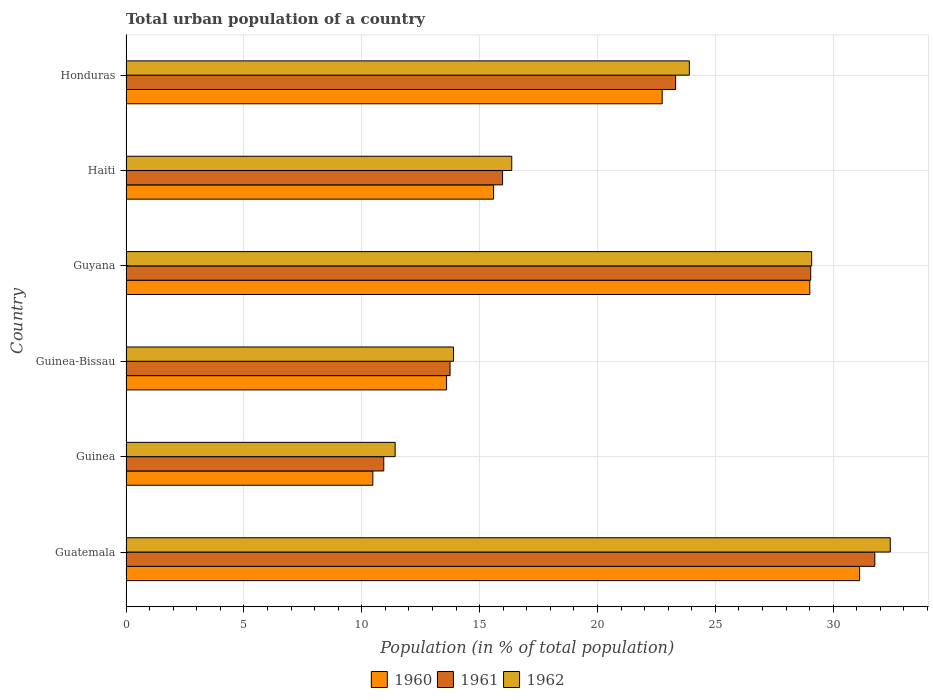How many different coloured bars are there?
Keep it short and to the point. 3. Are the number of bars on each tick of the Y-axis equal?
Your answer should be very brief. Yes. How many bars are there on the 2nd tick from the top?
Your answer should be compact. 3. What is the label of the 6th group of bars from the top?
Give a very brief answer. Guatemala. What is the urban population in 1960 in Guyana?
Keep it short and to the point. 29.01. Across all countries, what is the maximum urban population in 1962?
Provide a short and direct response. 32.42. Across all countries, what is the minimum urban population in 1960?
Offer a terse response. 10.47. In which country was the urban population in 1960 maximum?
Offer a terse response. Guatemala. In which country was the urban population in 1962 minimum?
Keep it short and to the point. Guinea. What is the total urban population in 1962 in the graph?
Provide a short and direct response. 127.09. What is the difference between the urban population in 1962 in Guinea and that in Honduras?
Your answer should be very brief. -12.48. What is the difference between the urban population in 1961 in Honduras and the urban population in 1960 in Guinea-Bissau?
Provide a short and direct response. 9.72. What is the average urban population in 1960 per country?
Give a very brief answer. 20.42. What is the difference between the urban population in 1961 and urban population in 1960 in Guatemala?
Provide a succinct answer. 0.65. What is the ratio of the urban population in 1960 in Guinea to that in Guinea-Bissau?
Give a very brief answer. 0.77. What is the difference between the highest and the second highest urban population in 1962?
Provide a succinct answer. 3.34. What is the difference between the highest and the lowest urban population in 1962?
Offer a very short reply. 21.01. In how many countries, is the urban population in 1962 greater than the average urban population in 1962 taken over all countries?
Your answer should be very brief. 3. Is the sum of the urban population in 1962 in Guinea-Bissau and Honduras greater than the maximum urban population in 1960 across all countries?
Ensure brevity in your answer.  Yes. What does the 3rd bar from the bottom in Guatemala represents?
Offer a very short reply. 1962. Is it the case that in every country, the sum of the urban population in 1960 and urban population in 1961 is greater than the urban population in 1962?
Your answer should be compact. Yes. Are all the bars in the graph horizontal?
Make the answer very short. Yes. What is the difference between two consecutive major ticks on the X-axis?
Offer a very short reply. 5. Does the graph contain grids?
Your answer should be compact. Yes. How are the legend labels stacked?
Offer a very short reply. Horizontal. What is the title of the graph?
Your answer should be very brief. Total urban population of a country. What is the label or title of the X-axis?
Make the answer very short. Population (in % of total population). What is the Population (in % of total population) in 1960 in Guatemala?
Ensure brevity in your answer.  31.12. What is the Population (in % of total population) in 1961 in Guatemala?
Make the answer very short. 31.77. What is the Population (in % of total population) in 1962 in Guatemala?
Give a very brief answer. 32.42. What is the Population (in % of total population) of 1960 in Guinea?
Provide a short and direct response. 10.47. What is the Population (in % of total population) of 1961 in Guinea?
Offer a very short reply. 10.94. What is the Population (in % of total population) in 1962 in Guinea?
Keep it short and to the point. 11.42. What is the Population (in % of total population) in 1961 in Guinea-Bissau?
Offer a very short reply. 13.75. What is the Population (in % of total population) of 1962 in Guinea-Bissau?
Give a very brief answer. 13.89. What is the Population (in % of total population) of 1960 in Guyana?
Your answer should be compact. 29.01. What is the Population (in % of total population) of 1961 in Guyana?
Give a very brief answer. 29.05. What is the Population (in % of total population) in 1962 in Guyana?
Provide a succinct answer. 29.09. What is the Population (in % of total population) in 1960 in Haiti?
Provide a succinct answer. 15.59. What is the Population (in % of total population) in 1961 in Haiti?
Your answer should be very brief. 15.97. What is the Population (in % of total population) of 1962 in Haiti?
Offer a very short reply. 16.36. What is the Population (in % of total population) in 1960 in Honduras?
Ensure brevity in your answer.  22.75. What is the Population (in % of total population) in 1961 in Honduras?
Ensure brevity in your answer.  23.32. What is the Population (in % of total population) in 1962 in Honduras?
Your answer should be very brief. 23.9. Across all countries, what is the maximum Population (in % of total population) in 1960?
Your answer should be compact. 31.12. Across all countries, what is the maximum Population (in % of total population) of 1961?
Provide a short and direct response. 31.77. Across all countries, what is the maximum Population (in % of total population) of 1962?
Your response must be concise. 32.42. Across all countries, what is the minimum Population (in % of total population) of 1960?
Provide a succinct answer. 10.47. Across all countries, what is the minimum Population (in % of total population) in 1961?
Make the answer very short. 10.94. Across all countries, what is the minimum Population (in % of total population) of 1962?
Your answer should be compact. 11.42. What is the total Population (in % of total population) in 1960 in the graph?
Offer a very short reply. 122.54. What is the total Population (in % of total population) of 1961 in the graph?
Offer a terse response. 124.79. What is the total Population (in % of total population) of 1962 in the graph?
Your answer should be compact. 127.09. What is the difference between the Population (in % of total population) in 1960 in Guatemala and that in Guinea?
Give a very brief answer. 20.65. What is the difference between the Population (in % of total population) of 1961 in Guatemala and that in Guinea?
Make the answer very short. 20.83. What is the difference between the Population (in % of total population) of 1962 in Guatemala and that in Guinea?
Provide a short and direct response. 21.01. What is the difference between the Population (in % of total population) of 1960 in Guatemala and that in Guinea-Bissau?
Provide a short and direct response. 17.52. What is the difference between the Population (in % of total population) in 1961 in Guatemala and that in Guinea-Bissau?
Your answer should be compact. 18.02. What is the difference between the Population (in % of total population) in 1962 in Guatemala and that in Guinea-Bissau?
Offer a very short reply. 18.53. What is the difference between the Population (in % of total population) of 1960 in Guatemala and that in Guyana?
Provide a succinct answer. 2.11. What is the difference between the Population (in % of total population) of 1961 in Guatemala and that in Guyana?
Keep it short and to the point. 2.72. What is the difference between the Population (in % of total population) of 1962 in Guatemala and that in Guyana?
Ensure brevity in your answer.  3.33. What is the difference between the Population (in % of total population) in 1960 in Guatemala and that in Haiti?
Offer a very short reply. 15.53. What is the difference between the Population (in % of total population) in 1961 in Guatemala and that in Haiti?
Keep it short and to the point. 15.79. What is the difference between the Population (in % of total population) in 1962 in Guatemala and that in Haiti?
Keep it short and to the point. 16.06. What is the difference between the Population (in % of total population) in 1960 in Guatemala and that in Honduras?
Offer a very short reply. 8.37. What is the difference between the Population (in % of total population) in 1961 in Guatemala and that in Honduras?
Offer a very short reply. 8.45. What is the difference between the Population (in % of total population) of 1962 in Guatemala and that in Honduras?
Keep it short and to the point. 8.52. What is the difference between the Population (in % of total population) of 1960 in Guinea and that in Guinea-Bissau?
Your answer should be very brief. -3.13. What is the difference between the Population (in % of total population) of 1961 in Guinea and that in Guinea-Bissau?
Your answer should be compact. -2.81. What is the difference between the Population (in % of total population) of 1962 in Guinea and that in Guinea-Bissau?
Your answer should be compact. -2.48. What is the difference between the Population (in % of total population) of 1960 in Guinea and that in Guyana?
Give a very brief answer. -18.54. What is the difference between the Population (in % of total population) in 1961 in Guinea and that in Guyana?
Offer a terse response. -18.11. What is the difference between the Population (in % of total population) in 1962 in Guinea and that in Guyana?
Give a very brief answer. -17.67. What is the difference between the Population (in % of total population) in 1960 in Guinea and that in Haiti?
Your answer should be compact. -5.12. What is the difference between the Population (in % of total population) in 1961 in Guinea and that in Haiti?
Your answer should be very brief. -5.04. What is the difference between the Population (in % of total population) of 1962 in Guinea and that in Haiti?
Offer a very short reply. -4.95. What is the difference between the Population (in % of total population) of 1960 in Guinea and that in Honduras?
Offer a very short reply. -12.28. What is the difference between the Population (in % of total population) in 1961 in Guinea and that in Honduras?
Provide a succinct answer. -12.38. What is the difference between the Population (in % of total population) in 1962 in Guinea and that in Honduras?
Provide a short and direct response. -12.48. What is the difference between the Population (in % of total population) in 1960 in Guinea-Bissau and that in Guyana?
Keep it short and to the point. -15.41. What is the difference between the Population (in % of total population) of 1961 in Guinea-Bissau and that in Guyana?
Provide a short and direct response. -15.3. What is the difference between the Population (in % of total population) in 1962 in Guinea-Bissau and that in Guyana?
Ensure brevity in your answer.  -15.19. What is the difference between the Population (in % of total population) in 1960 in Guinea-Bissau and that in Haiti?
Give a very brief answer. -1.99. What is the difference between the Population (in % of total population) of 1961 in Guinea-Bissau and that in Haiti?
Your response must be concise. -2.23. What is the difference between the Population (in % of total population) in 1962 in Guinea-Bissau and that in Haiti?
Keep it short and to the point. -2.47. What is the difference between the Population (in % of total population) in 1960 in Guinea-Bissau and that in Honduras?
Ensure brevity in your answer.  -9.15. What is the difference between the Population (in % of total population) of 1961 in Guinea-Bissau and that in Honduras?
Offer a terse response. -9.57. What is the difference between the Population (in % of total population) of 1962 in Guinea-Bissau and that in Honduras?
Give a very brief answer. -10.01. What is the difference between the Population (in % of total population) in 1960 in Guyana and that in Haiti?
Keep it short and to the point. 13.42. What is the difference between the Population (in % of total population) in 1961 in Guyana and that in Haiti?
Make the answer very short. 13.07. What is the difference between the Population (in % of total population) of 1962 in Guyana and that in Haiti?
Ensure brevity in your answer.  12.72. What is the difference between the Population (in % of total population) of 1960 in Guyana and that in Honduras?
Your answer should be compact. 6.26. What is the difference between the Population (in % of total population) in 1961 in Guyana and that in Honduras?
Provide a short and direct response. 5.73. What is the difference between the Population (in % of total population) in 1962 in Guyana and that in Honduras?
Offer a very short reply. 5.19. What is the difference between the Population (in % of total population) in 1960 in Haiti and that in Honduras?
Your response must be concise. -7.15. What is the difference between the Population (in % of total population) in 1961 in Haiti and that in Honduras?
Your answer should be very brief. -7.34. What is the difference between the Population (in % of total population) in 1962 in Haiti and that in Honduras?
Give a very brief answer. -7.54. What is the difference between the Population (in % of total population) in 1960 in Guatemala and the Population (in % of total population) in 1961 in Guinea?
Provide a short and direct response. 20.18. What is the difference between the Population (in % of total population) of 1960 in Guatemala and the Population (in % of total population) of 1962 in Guinea?
Your answer should be very brief. 19.7. What is the difference between the Population (in % of total population) of 1961 in Guatemala and the Population (in % of total population) of 1962 in Guinea?
Ensure brevity in your answer.  20.35. What is the difference between the Population (in % of total population) in 1960 in Guatemala and the Population (in % of total population) in 1961 in Guinea-Bissau?
Your answer should be compact. 17.37. What is the difference between the Population (in % of total population) in 1960 in Guatemala and the Population (in % of total population) in 1962 in Guinea-Bissau?
Your answer should be compact. 17.23. What is the difference between the Population (in % of total population) of 1961 in Guatemala and the Population (in % of total population) of 1962 in Guinea-Bissau?
Ensure brevity in your answer.  17.87. What is the difference between the Population (in % of total population) in 1960 in Guatemala and the Population (in % of total population) in 1961 in Guyana?
Provide a short and direct response. 2.07. What is the difference between the Population (in % of total population) of 1960 in Guatemala and the Population (in % of total population) of 1962 in Guyana?
Offer a very short reply. 2.03. What is the difference between the Population (in % of total population) in 1961 in Guatemala and the Population (in % of total population) in 1962 in Guyana?
Offer a terse response. 2.68. What is the difference between the Population (in % of total population) of 1960 in Guatemala and the Population (in % of total population) of 1961 in Haiti?
Give a very brief answer. 15.15. What is the difference between the Population (in % of total population) of 1960 in Guatemala and the Population (in % of total population) of 1962 in Haiti?
Make the answer very short. 14.76. What is the difference between the Population (in % of total population) of 1961 in Guatemala and the Population (in % of total population) of 1962 in Haiti?
Ensure brevity in your answer.  15.4. What is the difference between the Population (in % of total population) in 1960 in Guatemala and the Population (in % of total population) in 1961 in Honduras?
Ensure brevity in your answer.  7.8. What is the difference between the Population (in % of total population) of 1960 in Guatemala and the Population (in % of total population) of 1962 in Honduras?
Provide a short and direct response. 7.22. What is the difference between the Population (in % of total population) in 1961 in Guatemala and the Population (in % of total population) in 1962 in Honduras?
Give a very brief answer. 7.87. What is the difference between the Population (in % of total population) in 1960 in Guinea and the Population (in % of total population) in 1961 in Guinea-Bissau?
Offer a very short reply. -3.27. What is the difference between the Population (in % of total population) of 1960 in Guinea and the Population (in % of total population) of 1962 in Guinea-Bissau?
Keep it short and to the point. -3.42. What is the difference between the Population (in % of total population) in 1961 in Guinea and the Population (in % of total population) in 1962 in Guinea-Bissau?
Ensure brevity in your answer.  -2.96. What is the difference between the Population (in % of total population) in 1960 in Guinea and the Population (in % of total population) in 1961 in Guyana?
Provide a succinct answer. -18.58. What is the difference between the Population (in % of total population) in 1960 in Guinea and the Population (in % of total population) in 1962 in Guyana?
Provide a short and direct response. -18.62. What is the difference between the Population (in % of total population) in 1961 in Guinea and the Population (in % of total population) in 1962 in Guyana?
Make the answer very short. -18.15. What is the difference between the Population (in % of total population) of 1960 in Guinea and the Population (in % of total population) of 1961 in Haiti?
Give a very brief answer. -5.5. What is the difference between the Population (in % of total population) of 1960 in Guinea and the Population (in % of total population) of 1962 in Haiti?
Your answer should be compact. -5.89. What is the difference between the Population (in % of total population) in 1961 in Guinea and the Population (in % of total population) in 1962 in Haiti?
Provide a succinct answer. -5.43. What is the difference between the Population (in % of total population) in 1960 in Guinea and the Population (in % of total population) in 1961 in Honduras?
Provide a succinct answer. -12.85. What is the difference between the Population (in % of total population) of 1960 in Guinea and the Population (in % of total population) of 1962 in Honduras?
Offer a very short reply. -13.43. What is the difference between the Population (in % of total population) of 1961 in Guinea and the Population (in % of total population) of 1962 in Honduras?
Ensure brevity in your answer.  -12.96. What is the difference between the Population (in % of total population) in 1960 in Guinea-Bissau and the Population (in % of total population) in 1961 in Guyana?
Provide a succinct answer. -15.45. What is the difference between the Population (in % of total population) of 1960 in Guinea-Bissau and the Population (in % of total population) of 1962 in Guyana?
Your answer should be compact. -15.49. What is the difference between the Population (in % of total population) in 1961 in Guinea-Bissau and the Population (in % of total population) in 1962 in Guyana?
Keep it short and to the point. -15.34. What is the difference between the Population (in % of total population) in 1960 in Guinea-Bissau and the Population (in % of total population) in 1961 in Haiti?
Provide a succinct answer. -2.38. What is the difference between the Population (in % of total population) in 1960 in Guinea-Bissau and the Population (in % of total population) in 1962 in Haiti?
Your answer should be very brief. -2.77. What is the difference between the Population (in % of total population) of 1961 in Guinea-Bissau and the Population (in % of total population) of 1962 in Haiti?
Your response must be concise. -2.62. What is the difference between the Population (in % of total population) in 1960 in Guinea-Bissau and the Population (in % of total population) in 1961 in Honduras?
Offer a very short reply. -9.72. What is the difference between the Population (in % of total population) in 1961 in Guinea-Bissau and the Population (in % of total population) in 1962 in Honduras?
Offer a very short reply. -10.15. What is the difference between the Population (in % of total population) in 1960 in Guyana and the Population (in % of total population) in 1961 in Haiti?
Provide a short and direct response. 13.03. What is the difference between the Population (in % of total population) in 1960 in Guyana and the Population (in % of total population) in 1962 in Haiti?
Your answer should be compact. 12.64. What is the difference between the Population (in % of total population) of 1961 in Guyana and the Population (in % of total population) of 1962 in Haiti?
Keep it short and to the point. 12.68. What is the difference between the Population (in % of total population) in 1960 in Guyana and the Population (in % of total population) in 1961 in Honduras?
Offer a terse response. 5.69. What is the difference between the Population (in % of total population) of 1960 in Guyana and the Population (in % of total population) of 1962 in Honduras?
Offer a terse response. 5.11. What is the difference between the Population (in % of total population) of 1961 in Guyana and the Population (in % of total population) of 1962 in Honduras?
Provide a short and direct response. 5.15. What is the difference between the Population (in % of total population) in 1960 in Haiti and the Population (in % of total population) in 1961 in Honduras?
Your answer should be very brief. -7.72. What is the difference between the Population (in % of total population) in 1960 in Haiti and the Population (in % of total population) in 1962 in Honduras?
Your answer should be very brief. -8.31. What is the difference between the Population (in % of total population) in 1961 in Haiti and the Population (in % of total population) in 1962 in Honduras?
Offer a terse response. -7.92. What is the average Population (in % of total population) in 1960 per country?
Provide a succinct answer. 20.42. What is the average Population (in % of total population) in 1961 per country?
Provide a succinct answer. 20.8. What is the average Population (in % of total population) in 1962 per country?
Ensure brevity in your answer.  21.18. What is the difference between the Population (in % of total population) of 1960 and Population (in % of total population) of 1961 in Guatemala?
Offer a very short reply. -0.65. What is the difference between the Population (in % of total population) of 1960 and Population (in % of total population) of 1962 in Guatemala?
Your response must be concise. -1.3. What is the difference between the Population (in % of total population) in 1961 and Population (in % of total population) in 1962 in Guatemala?
Your answer should be compact. -0.66. What is the difference between the Population (in % of total population) of 1960 and Population (in % of total population) of 1961 in Guinea?
Keep it short and to the point. -0.46. What is the difference between the Population (in % of total population) of 1960 and Population (in % of total population) of 1962 in Guinea?
Keep it short and to the point. -0.95. What is the difference between the Population (in % of total population) of 1961 and Population (in % of total population) of 1962 in Guinea?
Offer a very short reply. -0.48. What is the difference between the Population (in % of total population) in 1960 and Population (in % of total population) in 1961 in Guinea-Bissau?
Provide a succinct answer. -0.15. What is the difference between the Population (in % of total population) of 1960 and Population (in % of total population) of 1962 in Guinea-Bissau?
Provide a short and direct response. -0.29. What is the difference between the Population (in % of total population) of 1961 and Population (in % of total population) of 1962 in Guinea-Bissau?
Keep it short and to the point. -0.15. What is the difference between the Population (in % of total population) in 1960 and Population (in % of total population) in 1961 in Guyana?
Ensure brevity in your answer.  -0.04. What is the difference between the Population (in % of total population) of 1960 and Population (in % of total population) of 1962 in Guyana?
Offer a very short reply. -0.08. What is the difference between the Population (in % of total population) in 1961 and Population (in % of total population) in 1962 in Guyana?
Provide a short and direct response. -0.04. What is the difference between the Population (in % of total population) of 1960 and Population (in % of total population) of 1961 in Haiti?
Provide a succinct answer. -0.38. What is the difference between the Population (in % of total population) of 1960 and Population (in % of total population) of 1962 in Haiti?
Your answer should be compact. -0.77. What is the difference between the Population (in % of total population) in 1961 and Population (in % of total population) in 1962 in Haiti?
Your response must be concise. -0.39. What is the difference between the Population (in % of total population) of 1960 and Population (in % of total population) of 1961 in Honduras?
Ensure brevity in your answer.  -0.57. What is the difference between the Population (in % of total population) of 1960 and Population (in % of total population) of 1962 in Honduras?
Your answer should be very brief. -1.15. What is the difference between the Population (in % of total population) in 1961 and Population (in % of total population) in 1962 in Honduras?
Your answer should be compact. -0.58. What is the ratio of the Population (in % of total population) of 1960 in Guatemala to that in Guinea?
Provide a succinct answer. 2.97. What is the ratio of the Population (in % of total population) of 1961 in Guatemala to that in Guinea?
Your answer should be compact. 2.9. What is the ratio of the Population (in % of total population) of 1962 in Guatemala to that in Guinea?
Ensure brevity in your answer.  2.84. What is the ratio of the Population (in % of total population) in 1960 in Guatemala to that in Guinea-Bissau?
Your answer should be very brief. 2.29. What is the ratio of the Population (in % of total population) in 1961 in Guatemala to that in Guinea-Bissau?
Provide a short and direct response. 2.31. What is the ratio of the Population (in % of total population) of 1962 in Guatemala to that in Guinea-Bissau?
Your response must be concise. 2.33. What is the ratio of the Population (in % of total population) in 1960 in Guatemala to that in Guyana?
Ensure brevity in your answer.  1.07. What is the ratio of the Population (in % of total population) of 1961 in Guatemala to that in Guyana?
Keep it short and to the point. 1.09. What is the ratio of the Population (in % of total population) in 1962 in Guatemala to that in Guyana?
Your answer should be very brief. 1.11. What is the ratio of the Population (in % of total population) of 1960 in Guatemala to that in Haiti?
Give a very brief answer. 2. What is the ratio of the Population (in % of total population) of 1961 in Guatemala to that in Haiti?
Keep it short and to the point. 1.99. What is the ratio of the Population (in % of total population) of 1962 in Guatemala to that in Haiti?
Offer a very short reply. 1.98. What is the ratio of the Population (in % of total population) in 1960 in Guatemala to that in Honduras?
Ensure brevity in your answer.  1.37. What is the ratio of the Population (in % of total population) of 1961 in Guatemala to that in Honduras?
Your answer should be very brief. 1.36. What is the ratio of the Population (in % of total population) in 1962 in Guatemala to that in Honduras?
Keep it short and to the point. 1.36. What is the ratio of the Population (in % of total population) of 1960 in Guinea to that in Guinea-Bissau?
Make the answer very short. 0.77. What is the ratio of the Population (in % of total population) in 1961 in Guinea to that in Guinea-Bissau?
Provide a short and direct response. 0.8. What is the ratio of the Population (in % of total population) of 1962 in Guinea to that in Guinea-Bissau?
Provide a succinct answer. 0.82. What is the ratio of the Population (in % of total population) of 1960 in Guinea to that in Guyana?
Make the answer very short. 0.36. What is the ratio of the Population (in % of total population) in 1961 in Guinea to that in Guyana?
Give a very brief answer. 0.38. What is the ratio of the Population (in % of total population) of 1962 in Guinea to that in Guyana?
Offer a terse response. 0.39. What is the ratio of the Population (in % of total population) of 1960 in Guinea to that in Haiti?
Provide a succinct answer. 0.67. What is the ratio of the Population (in % of total population) of 1961 in Guinea to that in Haiti?
Give a very brief answer. 0.68. What is the ratio of the Population (in % of total population) of 1962 in Guinea to that in Haiti?
Ensure brevity in your answer.  0.7. What is the ratio of the Population (in % of total population) in 1960 in Guinea to that in Honduras?
Your answer should be compact. 0.46. What is the ratio of the Population (in % of total population) in 1961 in Guinea to that in Honduras?
Your answer should be compact. 0.47. What is the ratio of the Population (in % of total population) of 1962 in Guinea to that in Honduras?
Offer a terse response. 0.48. What is the ratio of the Population (in % of total population) in 1960 in Guinea-Bissau to that in Guyana?
Offer a very short reply. 0.47. What is the ratio of the Population (in % of total population) of 1961 in Guinea-Bissau to that in Guyana?
Give a very brief answer. 0.47. What is the ratio of the Population (in % of total population) in 1962 in Guinea-Bissau to that in Guyana?
Your answer should be compact. 0.48. What is the ratio of the Population (in % of total population) in 1960 in Guinea-Bissau to that in Haiti?
Offer a very short reply. 0.87. What is the ratio of the Population (in % of total population) in 1961 in Guinea-Bissau to that in Haiti?
Your answer should be very brief. 0.86. What is the ratio of the Population (in % of total population) of 1962 in Guinea-Bissau to that in Haiti?
Offer a very short reply. 0.85. What is the ratio of the Population (in % of total population) of 1960 in Guinea-Bissau to that in Honduras?
Your response must be concise. 0.6. What is the ratio of the Population (in % of total population) in 1961 in Guinea-Bissau to that in Honduras?
Your answer should be very brief. 0.59. What is the ratio of the Population (in % of total population) in 1962 in Guinea-Bissau to that in Honduras?
Your answer should be very brief. 0.58. What is the ratio of the Population (in % of total population) in 1960 in Guyana to that in Haiti?
Give a very brief answer. 1.86. What is the ratio of the Population (in % of total population) in 1961 in Guyana to that in Haiti?
Give a very brief answer. 1.82. What is the ratio of the Population (in % of total population) of 1962 in Guyana to that in Haiti?
Your answer should be very brief. 1.78. What is the ratio of the Population (in % of total population) of 1960 in Guyana to that in Honduras?
Your response must be concise. 1.28. What is the ratio of the Population (in % of total population) of 1961 in Guyana to that in Honduras?
Give a very brief answer. 1.25. What is the ratio of the Population (in % of total population) of 1962 in Guyana to that in Honduras?
Your response must be concise. 1.22. What is the ratio of the Population (in % of total population) in 1960 in Haiti to that in Honduras?
Your answer should be compact. 0.69. What is the ratio of the Population (in % of total population) in 1961 in Haiti to that in Honduras?
Ensure brevity in your answer.  0.69. What is the ratio of the Population (in % of total population) of 1962 in Haiti to that in Honduras?
Give a very brief answer. 0.68. What is the difference between the highest and the second highest Population (in % of total population) of 1960?
Your response must be concise. 2.11. What is the difference between the highest and the second highest Population (in % of total population) of 1961?
Ensure brevity in your answer.  2.72. What is the difference between the highest and the second highest Population (in % of total population) of 1962?
Ensure brevity in your answer.  3.33. What is the difference between the highest and the lowest Population (in % of total population) in 1960?
Provide a succinct answer. 20.65. What is the difference between the highest and the lowest Population (in % of total population) of 1961?
Your answer should be compact. 20.83. What is the difference between the highest and the lowest Population (in % of total population) in 1962?
Offer a terse response. 21.01. 